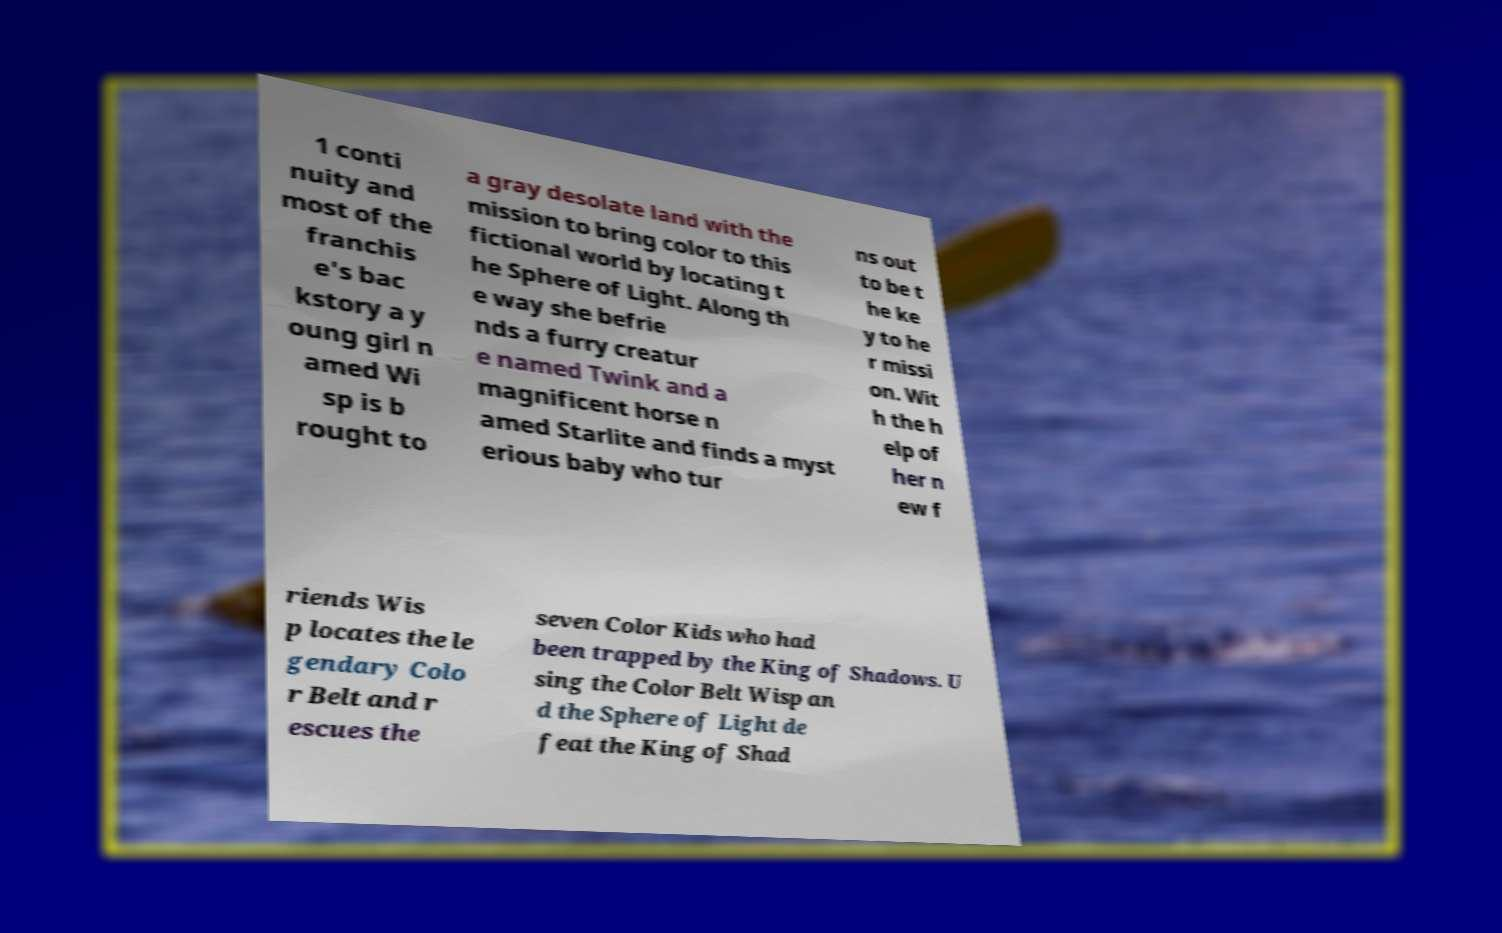What messages or text are displayed in this image? I need them in a readable, typed format. 1 conti nuity and most of the franchis e's bac kstory a y oung girl n amed Wi sp is b rought to a gray desolate land with the mission to bring color to this fictional world by locating t he Sphere of Light. Along th e way she befrie nds a furry creatur e named Twink and a magnificent horse n amed Starlite and finds a myst erious baby who tur ns out to be t he ke y to he r missi on. Wit h the h elp of her n ew f riends Wis p locates the le gendary Colo r Belt and r escues the seven Color Kids who had been trapped by the King of Shadows. U sing the Color Belt Wisp an d the Sphere of Light de feat the King of Shad 